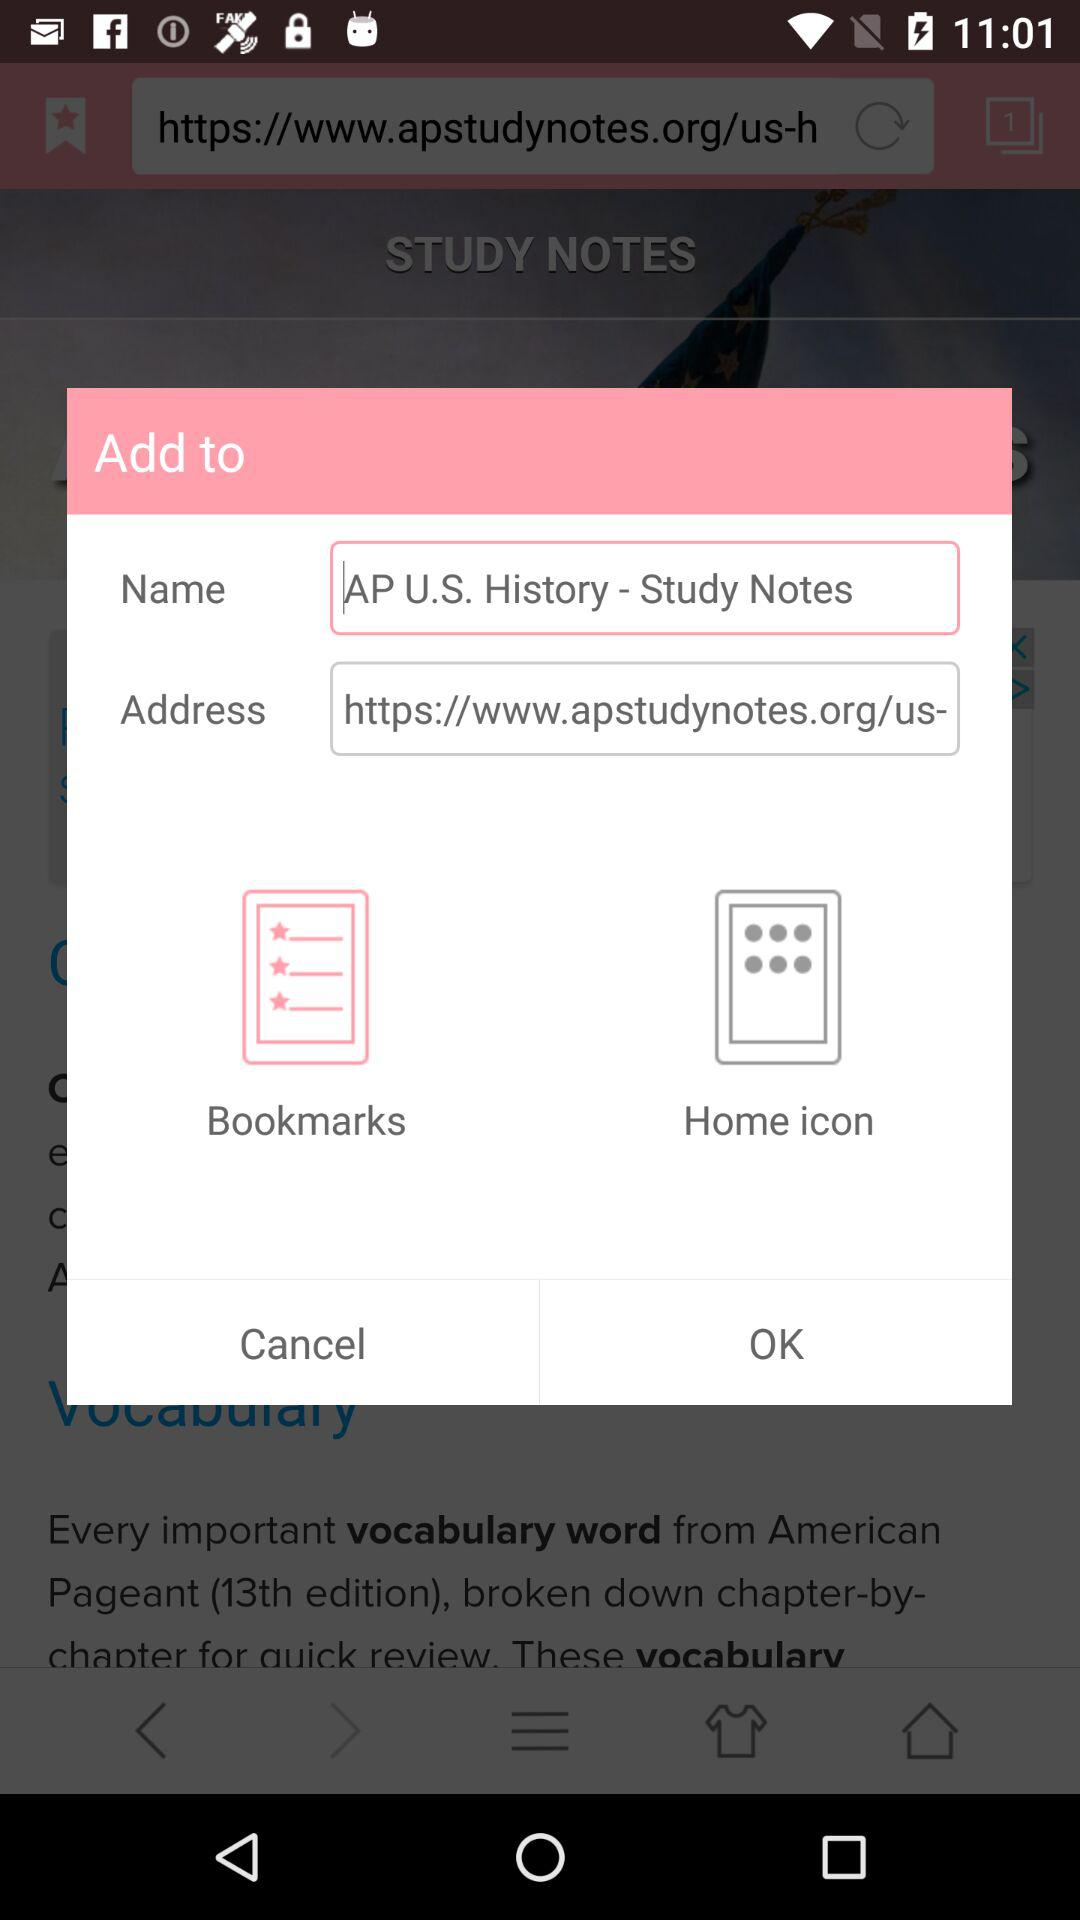What's the address? The address is https://www.apstudynotes.org/us-. 